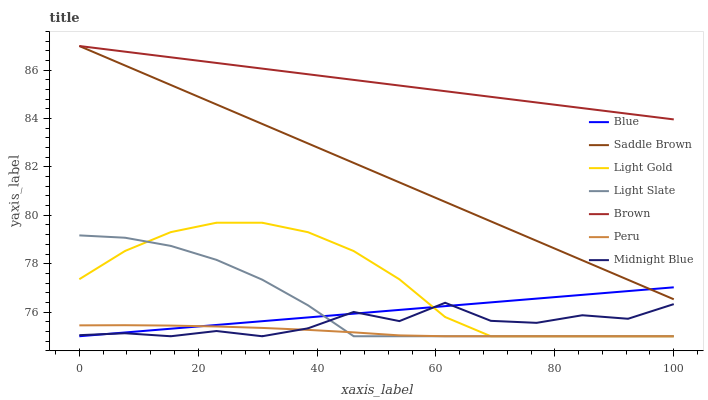Does Peru have the minimum area under the curve?
Answer yes or no. Yes. Does Brown have the maximum area under the curve?
Answer yes or no. Yes. Does Midnight Blue have the minimum area under the curve?
Answer yes or no. No. Does Midnight Blue have the maximum area under the curve?
Answer yes or no. No. Is Saddle Brown the smoothest?
Answer yes or no. Yes. Is Midnight Blue the roughest?
Answer yes or no. Yes. Is Brown the smoothest?
Answer yes or no. No. Is Brown the roughest?
Answer yes or no. No. Does Blue have the lowest value?
Answer yes or no. Yes. Does Brown have the lowest value?
Answer yes or no. No. Does Saddle Brown have the highest value?
Answer yes or no. Yes. Does Midnight Blue have the highest value?
Answer yes or no. No. Is Light Slate less than Brown?
Answer yes or no. Yes. Is Saddle Brown greater than Light Gold?
Answer yes or no. Yes. Does Brown intersect Saddle Brown?
Answer yes or no. Yes. Is Brown less than Saddle Brown?
Answer yes or no. No. Is Brown greater than Saddle Brown?
Answer yes or no. No. Does Light Slate intersect Brown?
Answer yes or no. No. 